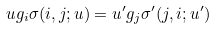Convert formula to latex. <formula><loc_0><loc_0><loc_500><loc_500>u g _ { i } \sigma ( i , j ; u ) = u ^ { \prime } g _ { j } \sigma ^ { \prime } ( j , i ; u ^ { \prime } )</formula> 